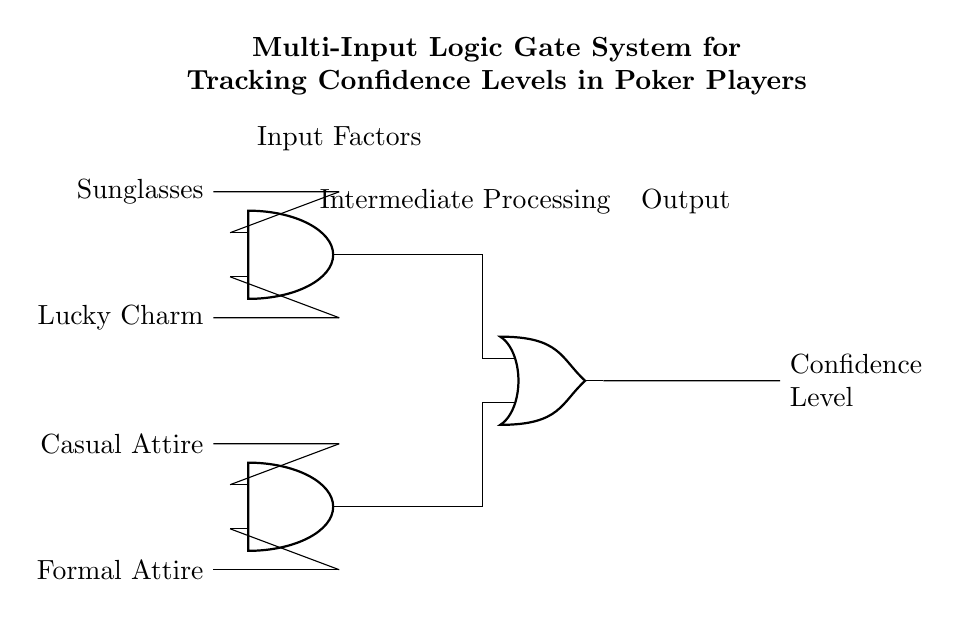What are the input factors in this circuit? The circuit diagram shows four input factors labeled as Formal Attire, Casual Attire, Lucky Charm, and Sunglasses. These are the variables being analyzed for their effect on confidence levels.
Answer: Formal Attire, Casual Attire, Lucky Charm, Sunglasses What type of logic gates are used in the circuit? The circuit uses AND gates for intermediate processing of certain combinations of inputs and an OR gate to combine the outputs of the AND gates. This indicates that the circuit processes inputs using both types of logic gates.
Answer: AND, OR How many AND gates are present in the circuit? The diagram explicitly shows two AND gates located between the input and output sections of the circuit. Each AND gate takes inputs from different sources.
Answer: Two What is the output of the logic gate system? The output of the system is labeled as "Confidence Level," which is the main result obtained after processing the input factors through the logic gates. This represents the overall confidence levels in poker players based on their attire.
Answer: Confidence Level How many inputs does each AND gate have? Each AND gate in this circuit has two inputs, as indicated by their connection points labeled in the diagram. This setup allows each gate to analyze pairs of input factors simultaneously.
Answer: Two What is the purpose of the OR gate in this circuit? The OR gate serves to combine the outputs from the two AND gates. If either AND gate produces a high output, the OR gate will indicate a high confidence level. It aggregates the results of the preliminary logic operations.
Answer: To combine outputs 